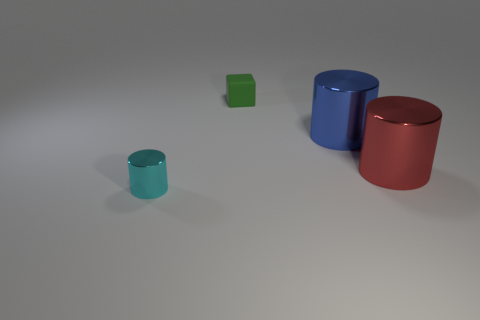Are there the same number of tiny cylinders that are on the left side of the large red cylinder and gray shiny cylinders? There are not the same number of tiny cylinders on the left side of the large red cylinder as there are gray shiny cylinders. Specifically, there is one tiny green cylinder on the left side of the red cylinder, and no gray shiny cylinders are present. 